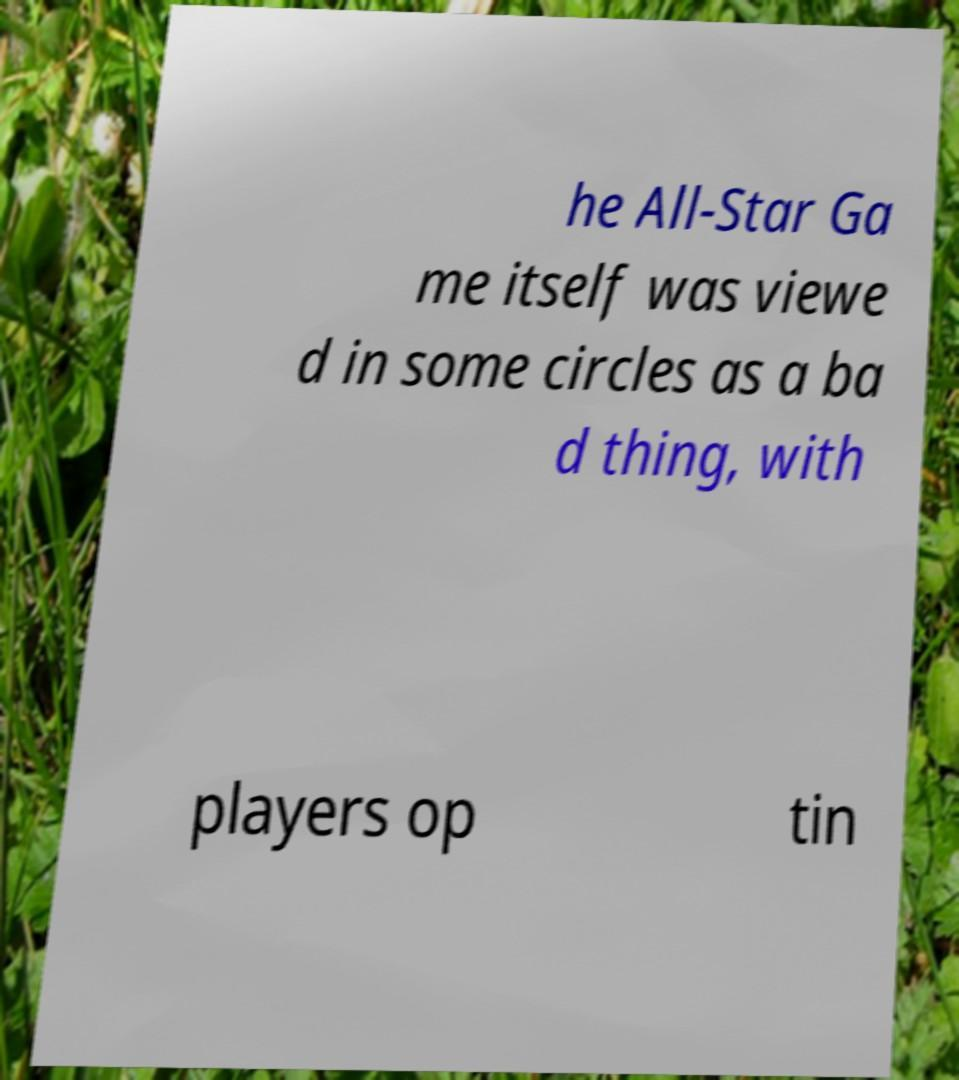Could you extract and type out the text from this image? he All-Star Ga me itself was viewe d in some circles as a ba d thing, with players op tin 